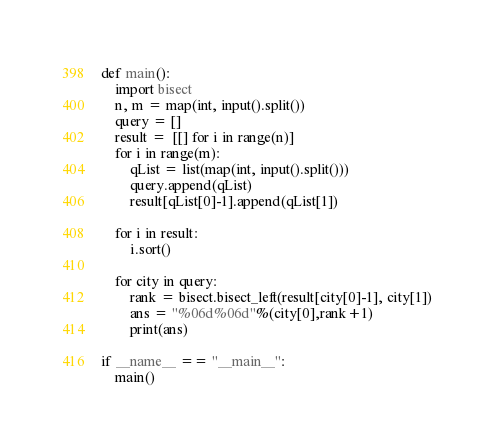Convert code to text. <code><loc_0><loc_0><loc_500><loc_500><_Python_>def main():
    import bisect
    n, m = map(int, input().split())
    query = []
    result =  [[] for i in range(n)]
    for i in range(m):
        qList = list(map(int, input().split()))
        query.append(qList)
        result[qList[0]-1].append(qList[1])
 
    for i in result:
        i.sort()
 
    for city in query:
        rank = bisect.bisect_left(result[city[0]-1], city[1])
        ans = "%06d%06d"%(city[0],rank+1)
        print(ans)
 
if __name__ == "__main__":
    main()</code> 